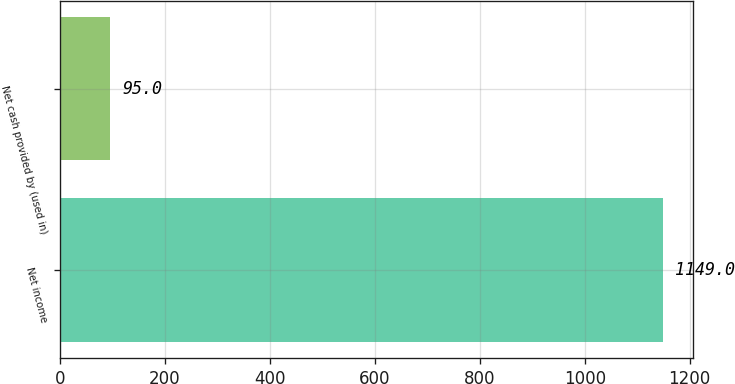<chart> <loc_0><loc_0><loc_500><loc_500><bar_chart><fcel>Net income<fcel>Net cash provided by (used in)<nl><fcel>1149<fcel>95<nl></chart> 